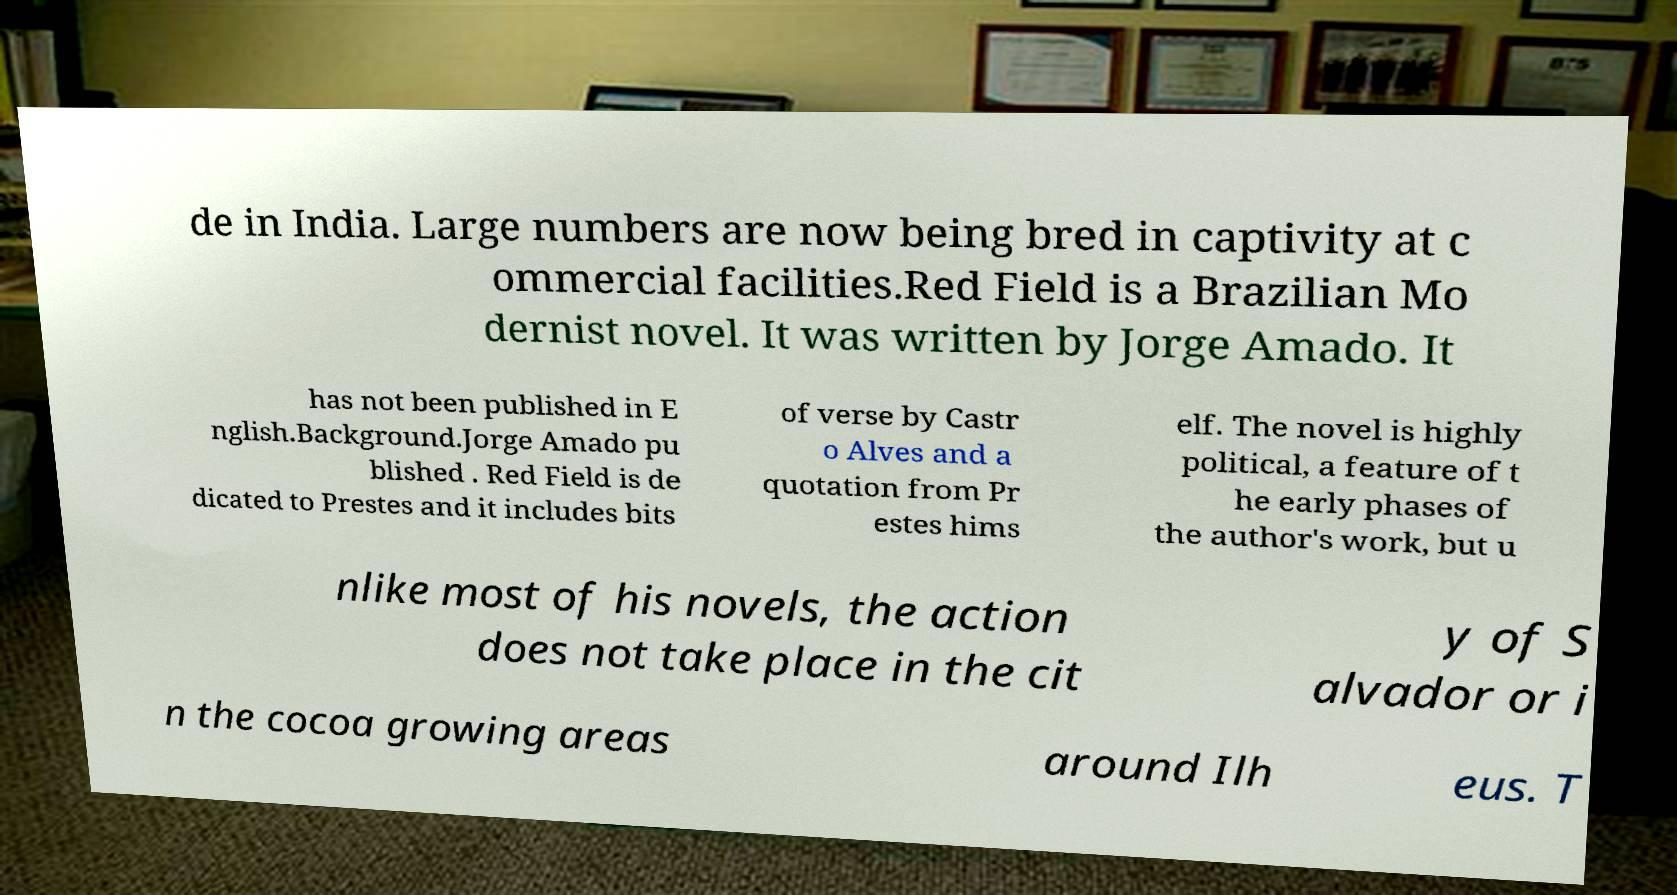There's text embedded in this image that I need extracted. Can you transcribe it verbatim? de in India. Large numbers are now being bred in captivity at c ommercial facilities.Red Field is a Brazilian Mo dernist novel. It was written by Jorge Amado. It has not been published in E nglish.Background.Jorge Amado pu blished . Red Field is de dicated to Prestes and it includes bits of verse by Castr o Alves and a quotation from Pr estes hims elf. The novel is highly political, a feature of t he early phases of the author's work, but u nlike most of his novels, the action does not take place in the cit y of S alvador or i n the cocoa growing areas around Ilh eus. T 